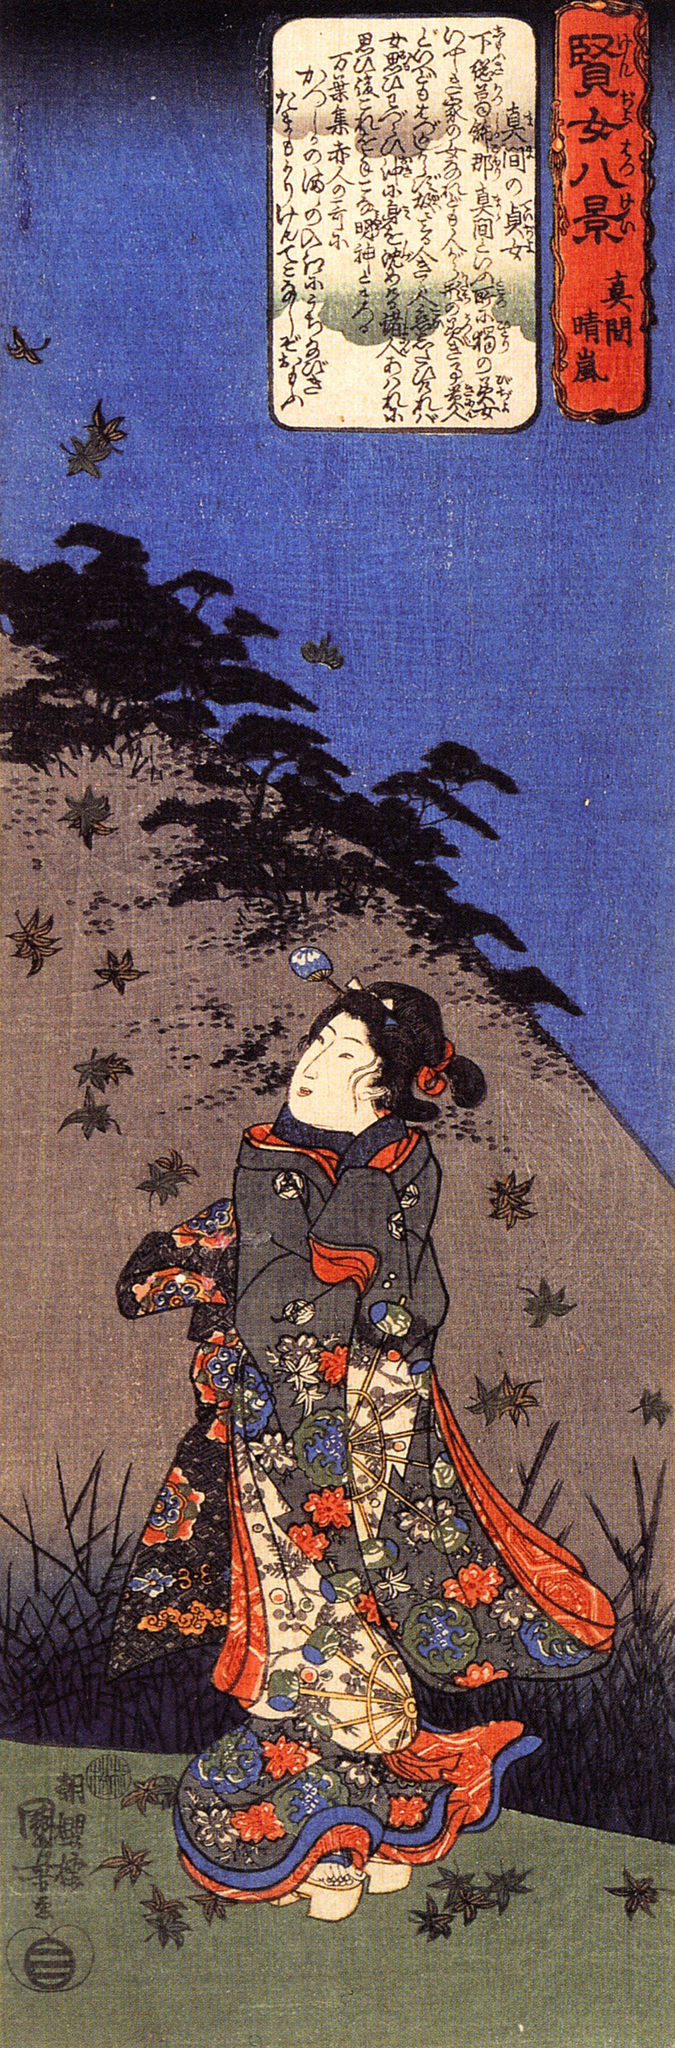Imagine a story inspired by this image. On a serene autumn evening, Akiko wandered through the ancient forest at the base of Mount Fuji, her vibrant kimono a brilliant contrast against the earthy tones of fallen leaves. She was on a quest to find the mysterious Tengu, a mythical creature rumored to inhabit the mountain's peak. Legend had it that those who caught a glimpse of the Tengu were granted a single wish. As Akiko gazed upwards, the flapping of wings interrupted her thoughts, and she spotted a flock of birds soaring towards the summit. With renewed determination, she followed their path, each step bringing her closer to her destiny. 